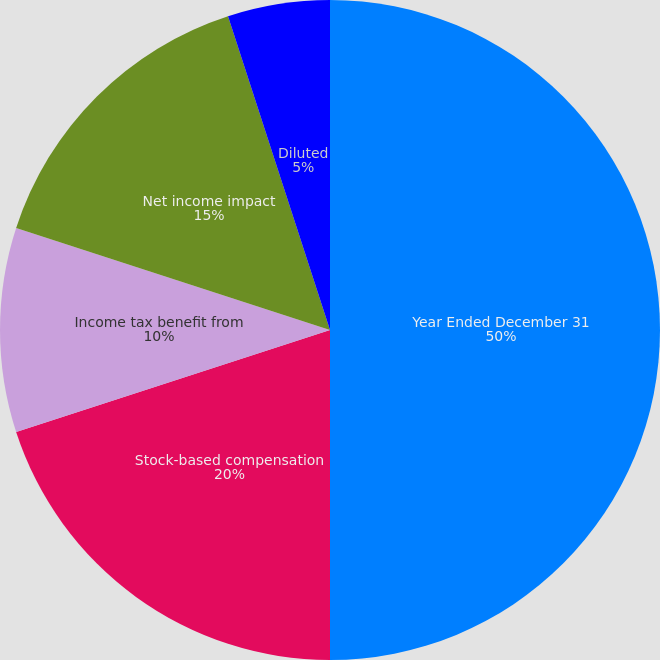Convert chart. <chart><loc_0><loc_0><loc_500><loc_500><pie_chart><fcel>Year Ended December 31<fcel>Stock-based compensation<fcel>Income tax benefit from<fcel>Net income impact<fcel>Basic<fcel>Diluted<nl><fcel>50.0%<fcel>20.0%<fcel>10.0%<fcel>15.0%<fcel>0.0%<fcel>5.0%<nl></chart> 